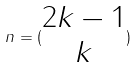<formula> <loc_0><loc_0><loc_500><loc_500>n = ( \begin{matrix} 2 k - 1 \\ k \end{matrix} )</formula> 